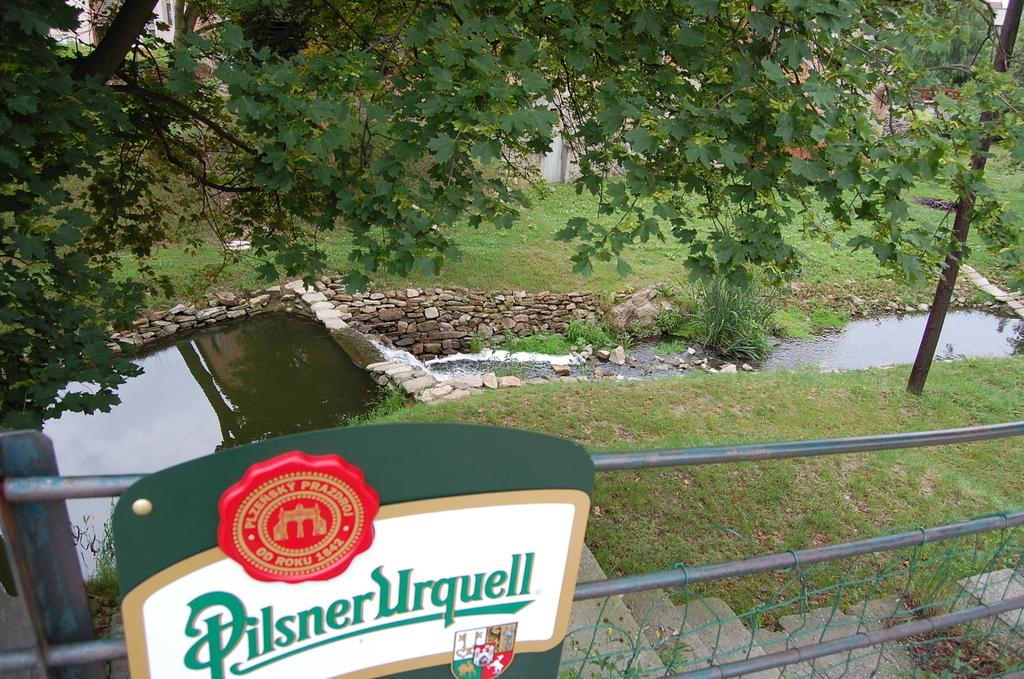What type of water feature is present in the image? There is a small pond in the image. What is the primary substance visible in the pond? There is water in the image. What type of objects can be seen near the pond? There are stones in the image. What type of signage is present in the image? There is a sign board in the image. What type of barrier is present in the image? There is a fence in the image. What type of structure is present in the image? There is a building in the image. What type of vegetation is present in the image? There are trees and grass in the image. What type of vertical structure is present in the image? There is a pole in the image. What type of soap is being used to clean the bear in the image? There is no bear or soap present in the image. What type of hall is visible in the image? There is no hall present in the image. 